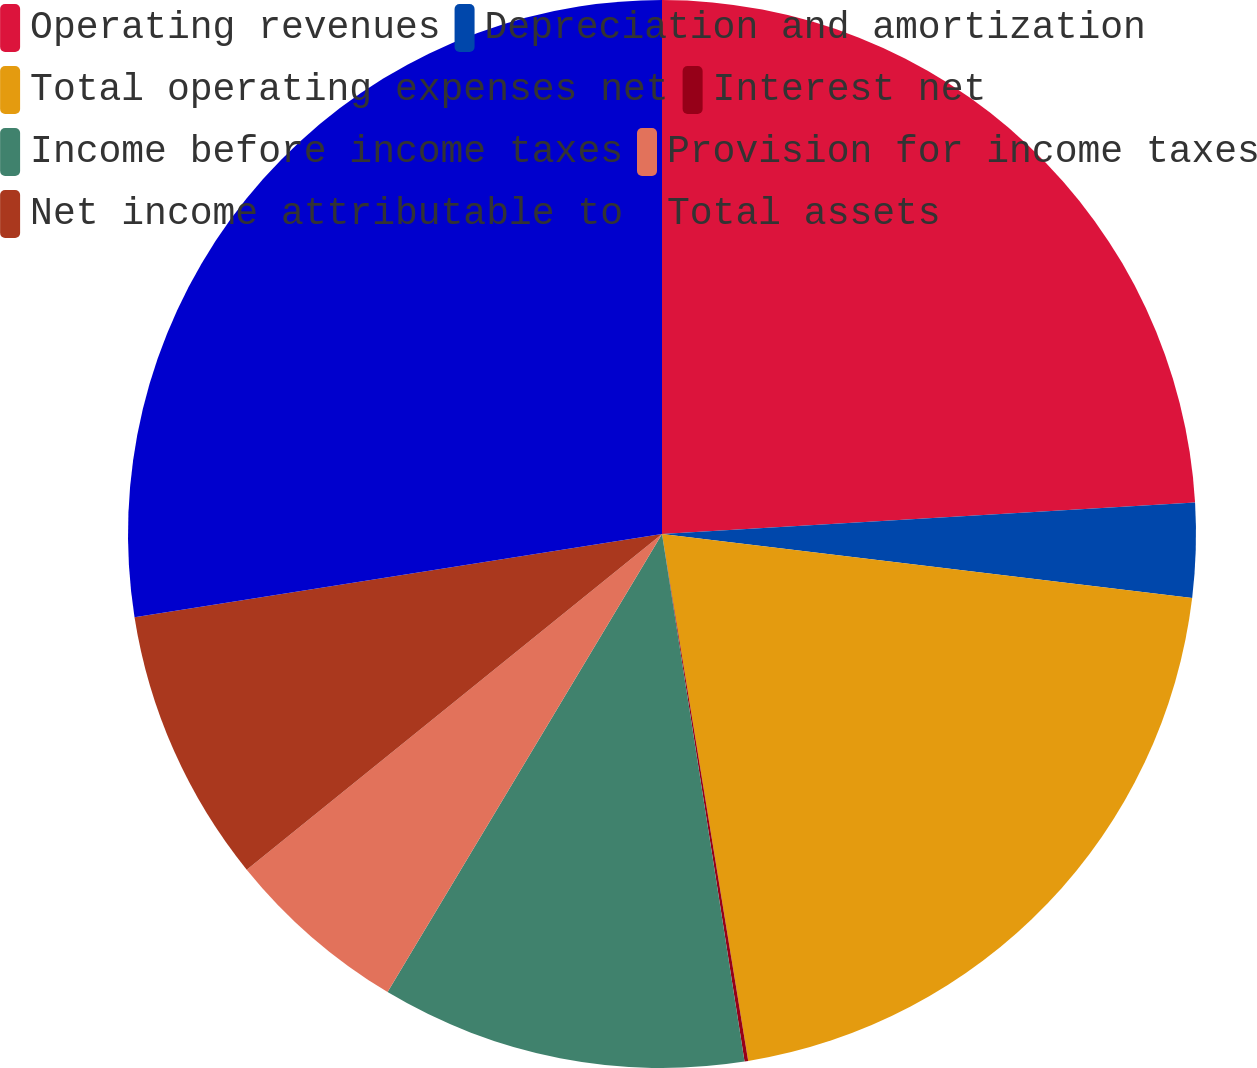Convert chart. <chart><loc_0><loc_0><loc_500><loc_500><pie_chart><fcel>Operating revenues<fcel>Depreciation and amortization<fcel>Total operating expenses net<fcel>Interest net<fcel>Income before income taxes<fcel>Provision for income taxes<fcel>Net income attributable to<fcel>Total assets<nl><fcel>24.06%<fcel>2.85%<fcel>20.51%<fcel>0.11%<fcel>11.06%<fcel>5.59%<fcel>8.33%<fcel>27.49%<nl></chart> 